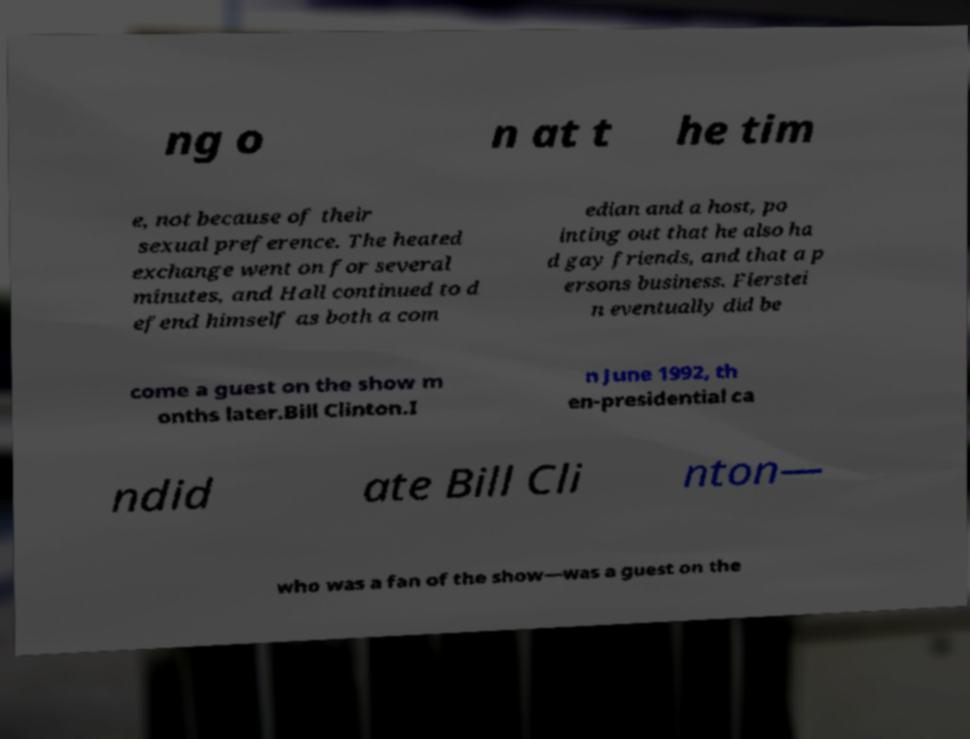Please identify and transcribe the text found in this image. ng o n at t he tim e, not because of their sexual preference. The heated exchange went on for several minutes, and Hall continued to d efend himself as both a com edian and a host, po inting out that he also ha d gay friends, and that a p ersons business. Fierstei n eventually did be come a guest on the show m onths later.Bill Clinton.I n June 1992, th en-presidential ca ndid ate Bill Cli nton— who was a fan of the show—was a guest on the 